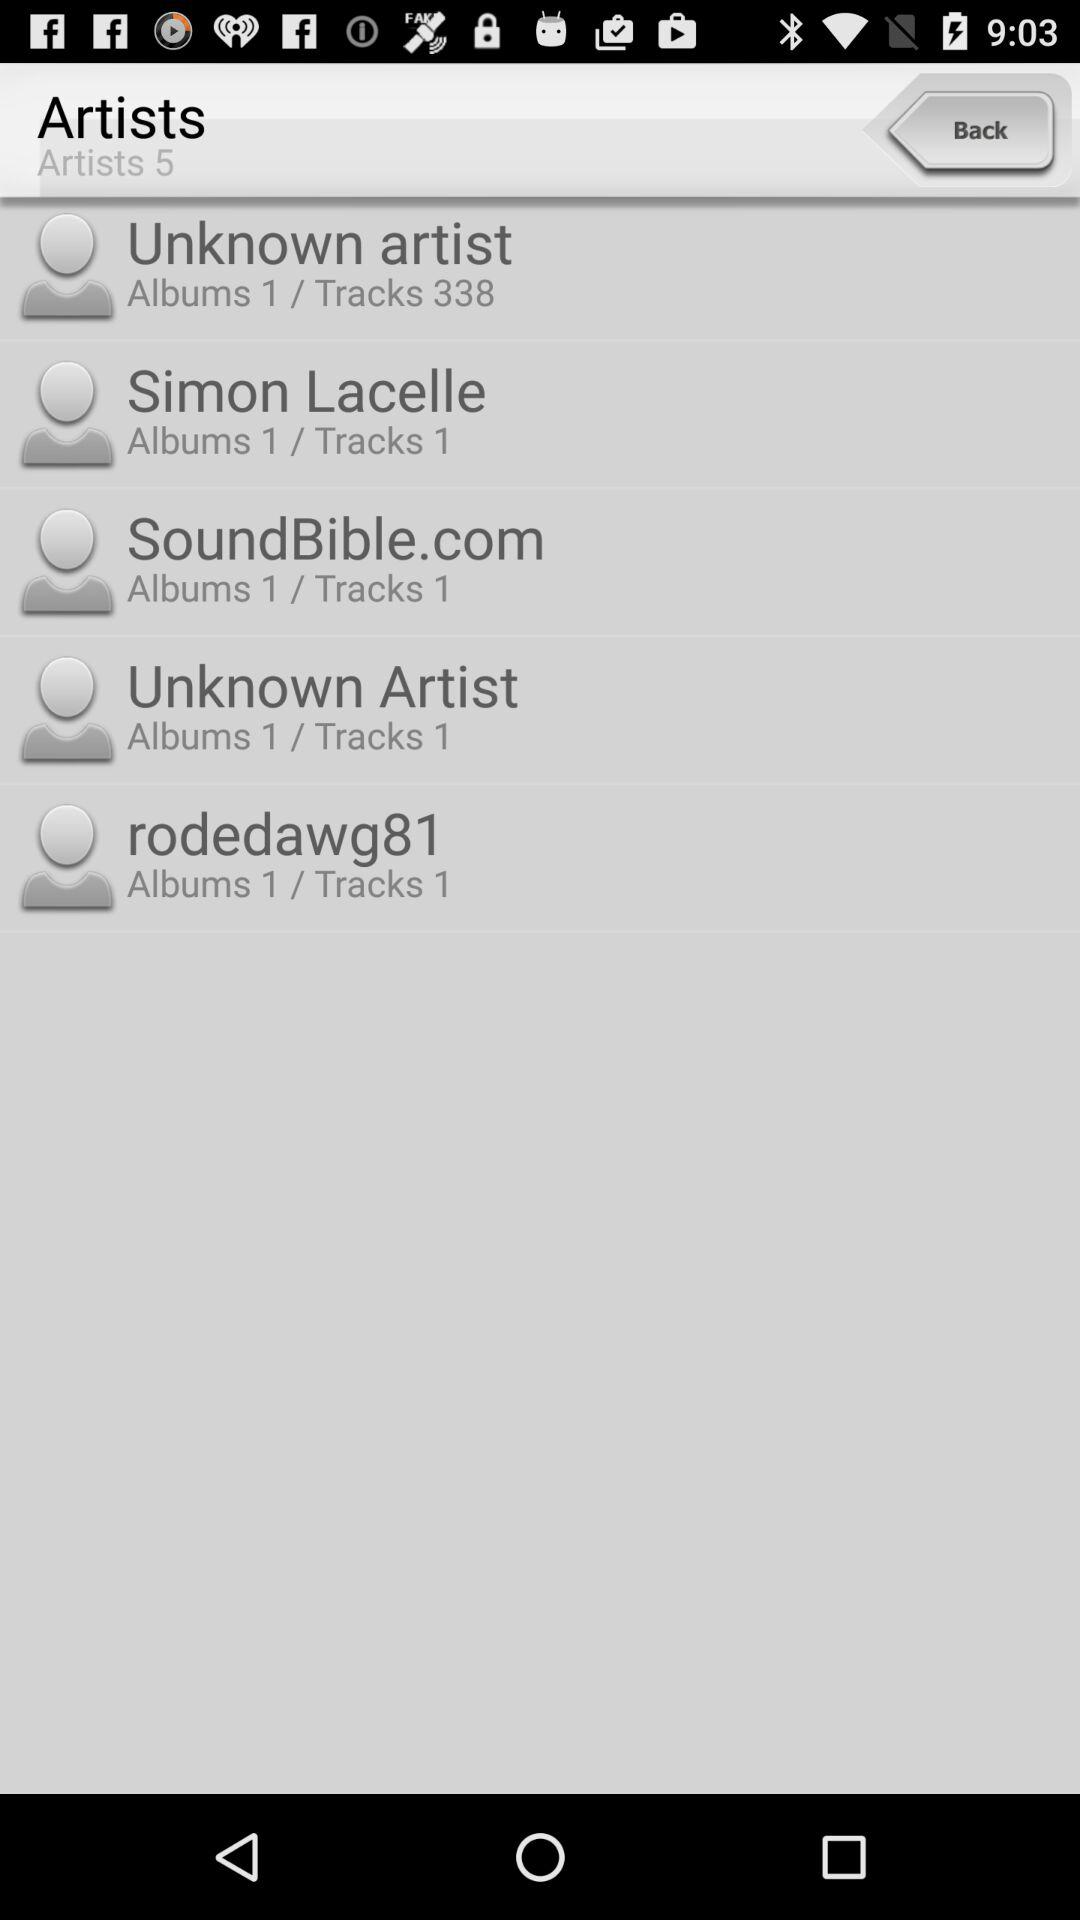How many artists in total are there? There are 5 artists. 